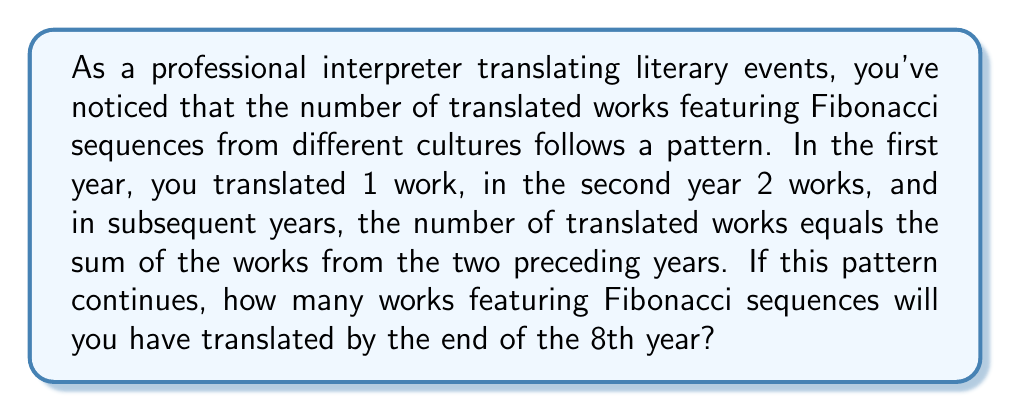Help me with this question. Let's break this down step-by-step:

1) First, let's recall the Fibonacci sequence: Each number is the sum of the two preceding ones.

2) Let's list out the number of works translated each year:
   Year 1: 1 work
   Year 2: 2 works
   Year 3: 1 + 2 = 3 works
   Year 4: 2 + 3 = 5 works
   Year 5: 3 + 5 = 8 works
   Year 6: 5 + 8 = 13 works
   Year 7: 8 + 13 = 21 works
   Year 8: 13 + 21 = 34 works

3) Now, to find the total number of works translated by the end of the 8th year, we need to sum all these numbers:

   $$\sum_{i=1}^{8} F_i = 1 + 2 + 3 + 5 + 8 + 13 + 21 + 34$$

4) Where $F_i$ represents the $i$-th Fibonacci number.

5) Calculating this sum:
   $$1 + 2 + 3 + 5 + 8 + 13 + 21 + 34 = 87$$

Therefore, by the end of the 8th year, you will have translated a total of 87 works featuring Fibonacci sequences.
Answer: 87 